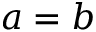Convert formula to latex. <formula><loc_0><loc_0><loc_500><loc_500>a = b</formula> 